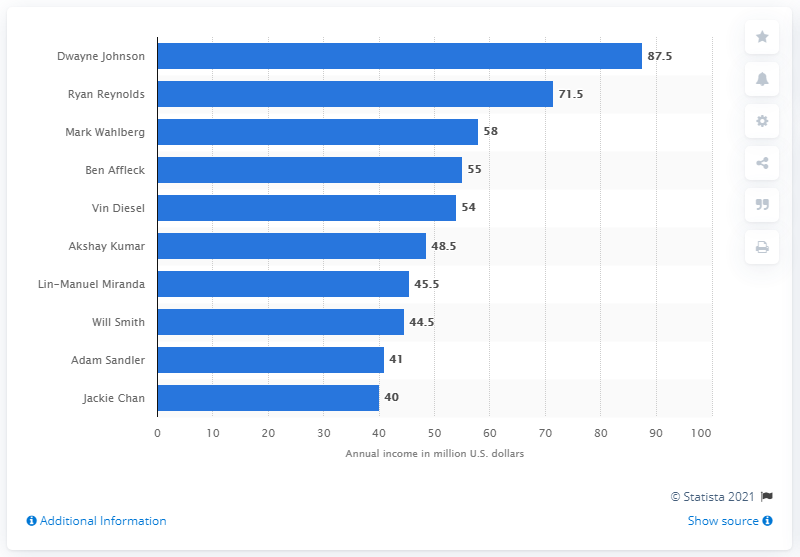Draw attention to some important aspects in this diagram. In 2020, Ryan Reynolds ranked second on the list of the best paid actors worldwide. According to a source, Bollywood actor Akshay Kumar earned 48.5 million U.S. dollars in a given period. Dwayne Johnson leads the list of best-paid actors worldwide in 2020. Dwayne Johnson earned $87.5 million in the United States. 